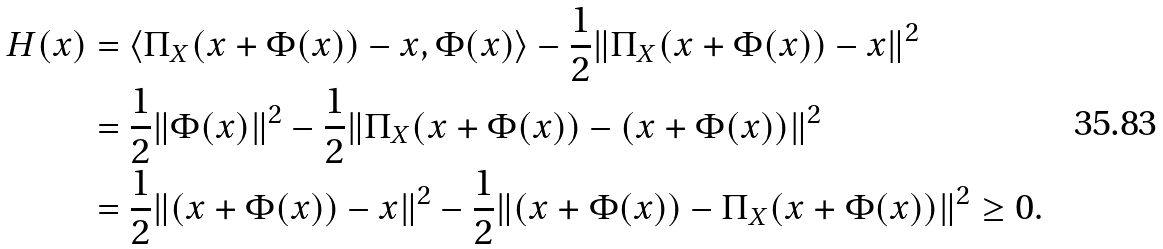Convert formula to latex. <formula><loc_0><loc_0><loc_500><loc_500>H ( x ) & = \langle \Pi _ { X } ( x + \Phi ( x ) ) - x , \Phi ( x ) \rangle - \frac { 1 } { 2 } \| \Pi _ { X } ( x + \Phi ( x ) ) - x \| ^ { 2 } \\ & = \frac { 1 } { 2 } \| \Phi ( x ) \| ^ { 2 } - \frac { 1 } { 2 } \| \Pi _ { X } ( x + \Phi ( x ) ) - ( x + \Phi ( x ) ) \| ^ { 2 } \\ & = \frac { 1 } { 2 } \| ( x + \Phi ( x ) ) - x \| ^ { 2 } - \frac { 1 } { 2 } \| ( x + \Phi ( x ) ) - \Pi _ { X } ( x + \Phi ( x ) ) \| ^ { 2 } \geq 0 .</formula> 